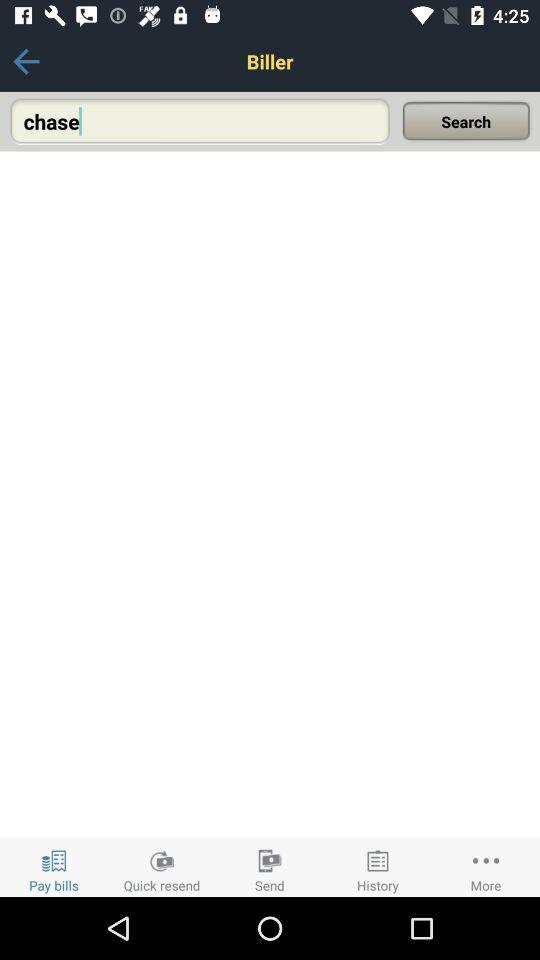What is the text input in the input field? The text input in the input field is "chase". 